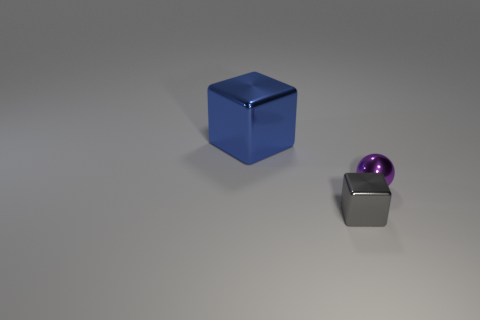Do the gray shiny thing and the blue thing have the same shape?
Provide a short and direct response. Yes. Are there fewer gray things that are behind the tiny gray metallic object than big purple spheres?
Your answer should be compact. No. There is a metal block behind the block that is in front of the blue metal cube; what is its color?
Keep it short and to the point. Blue. How big is the object on the right side of the shiny cube that is in front of the tiny metal object that is to the right of the gray shiny cube?
Keep it short and to the point. Small. Is the number of blue metal objects behind the large blue metal thing less than the number of big blue objects that are behind the gray metal object?
Keep it short and to the point. Yes. What number of other things have the same material as the tiny gray object?
Ensure brevity in your answer.  2. Is there a small gray metal block in front of the big blue object that is behind the thing that is in front of the small purple shiny thing?
Keep it short and to the point. Yes. What is the shape of the big blue object that is made of the same material as the purple sphere?
Offer a very short reply. Cube. Are there more gray shiny cubes than gray matte balls?
Keep it short and to the point. Yes. Is the shape of the small gray shiny object the same as the metallic thing that is right of the gray cube?
Your response must be concise. No. 